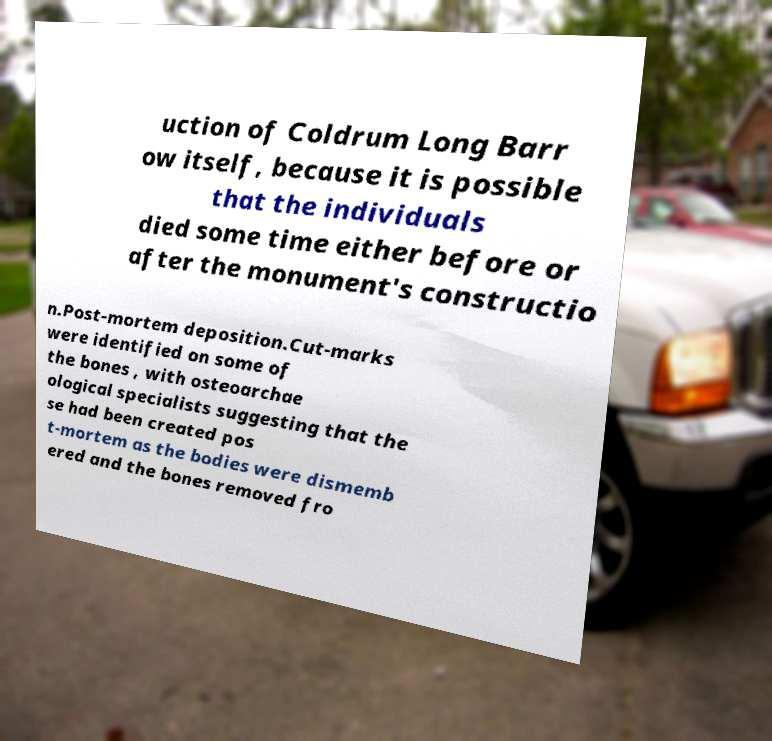Could you assist in decoding the text presented in this image and type it out clearly? uction of Coldrum Long Barr ow itself, because it is possible that the individuals died some time either before or after the monument's constructio n.Post-mortem deposition.Cut-marks were identified on some of the bones , with osteoarchae ological specialists suggesting that the se had been created pos t-mortem as the bodies were dismemb ered and the bones removed fro 